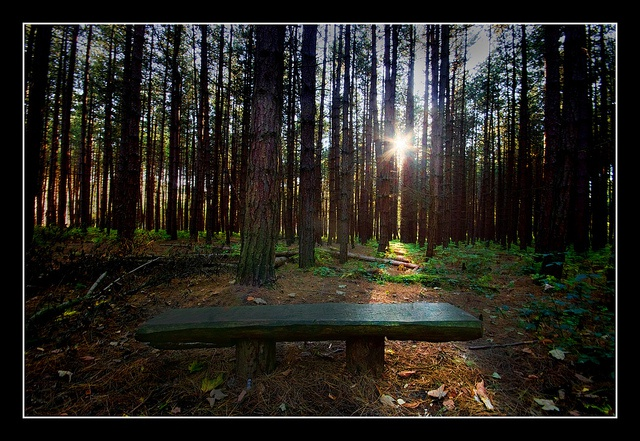Describe the objects in this image and their specific colors. I can see a bench in black, purple, teal, and gray tones in this image. 